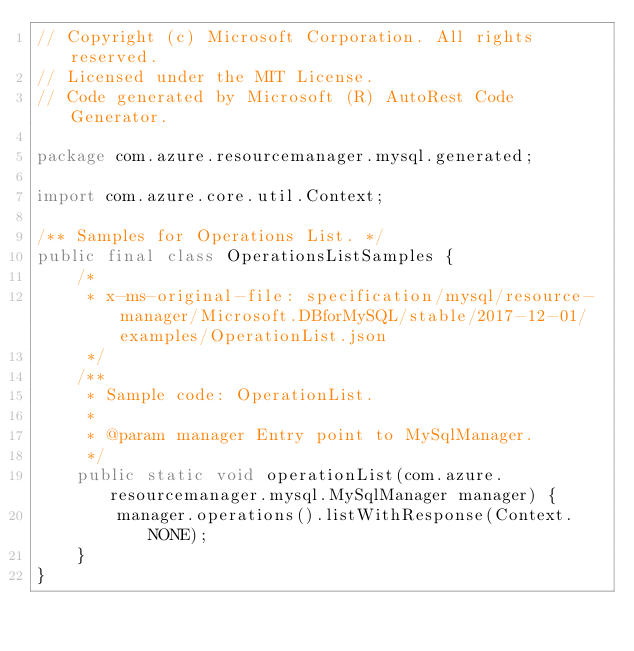Convert code to text. <code><loc_0><loc_0><loc_500><loc_500><_Java_>// Copyright (c) Microsoft Corporation. All rights reserved.
// Licensed under the MIT License.
// Code generated by Microsoft (R) AutoRest Code Generator.

package com.azure.resourcemanager.mysql.generated;

import com.azure.core.util.Context;

/** Samples for Operations List. */
public final class OperationsListSamples {
    /*
     * x-ms-original-file: specification/mysql/resource-manager/Microsoft.DBforMySQL/stable/2017-12-01/examples/OperationList.json
     */
    /**
     * Sample code: OperationList.
     *
     * @param manager Entry point to MySqlManager.
     */
    public static void operationList(com.azure.resourcemanager.mysql.MySqlManager manager) {
        manager.operations().listWithResponse(Context.NONE);
    }
}
</code> 